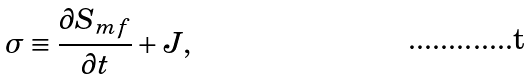<formula> <loc_0><loc_0><loc_500><loc_500>\sigma \equiv \frac { \partial S _ { m f } } { \partial t } + J ,</formula> 